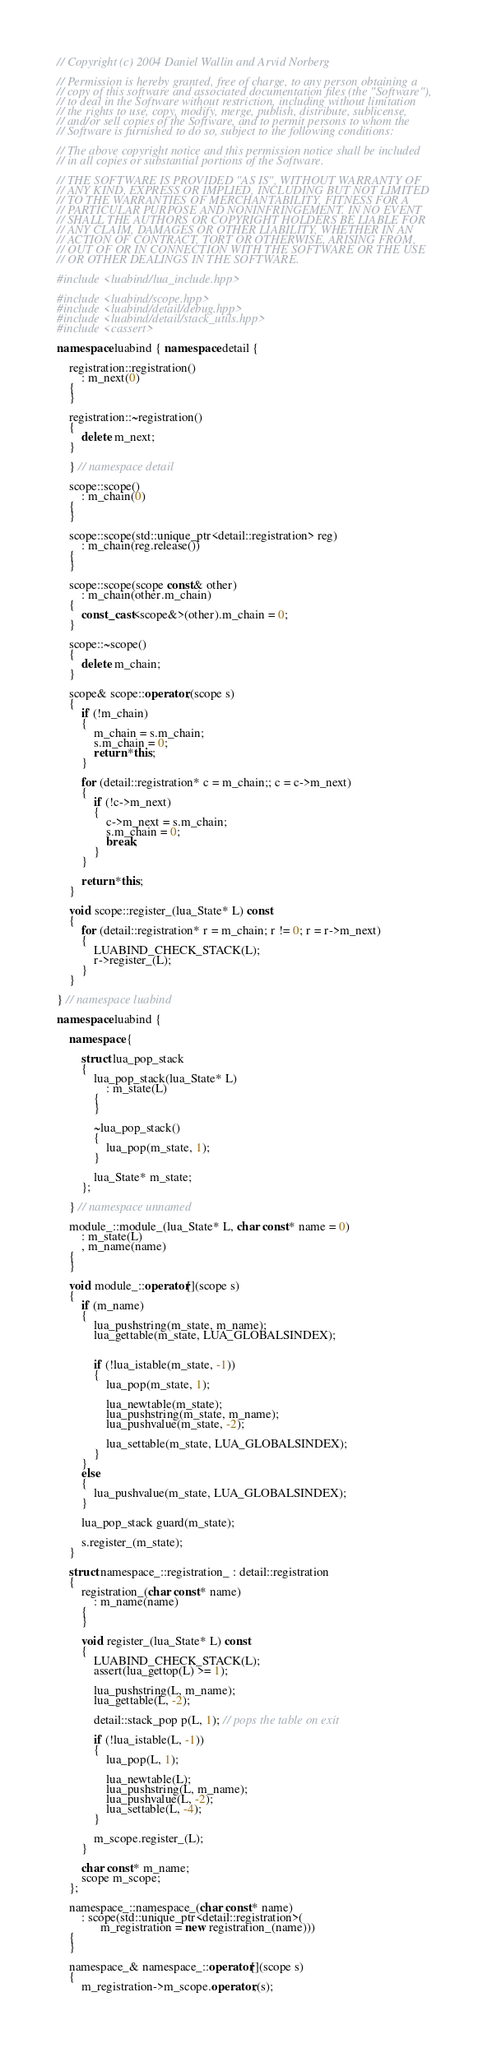Convert code to text. <code><loc_0><loc_0><loc_500><loc_500><_C++_>// Copyright (c) 2004 Daniel Wallin and Arvid Norberg

// Permission is hereby granted, free of charge, to any person obtaining a
// copy of this software and associated documentation files (the "Software"),
// to deal in the Software without restriction, including without limitation
// the rights to use, copy, modify, merge, publish, distribute, sublicense,
// and/or sell copies of the Software, and to permit persons to whom the
// Software is furnished to do so, subject to the following conditions:

// The above copyright notice and this permission notice shall be included
// in all copies or substantial portions of the Software.

// THE SOFTWARE IS PROVIDED "AS IS", WITHOUT WARRANTY OF
// ANY KIND, EXPRESS OR IMPLIED, INCLUDING BUT NOT LIMITED
// TO THE WARRANTIES OF MERCHANTABILITY, FITNESS FOR A
// PARTICULAR PURPOSE AND NONINFRINGEMENT. IN NO EVENT
// SHALL THE AUTHORS OR COPYRIGHT HOLDERS BE LIABLE FOR
// ANY CLAIM, DAMAGES OR OTHER LIABILITY, WHETHER IN AN
// ACTION OF CONTRACT, TORT OR OTHERWISE, ARISING FROM,
// OUT OF OR IN CONNECTION WITH THE SOFTWARE OR THE USE
// OR OTHER DEALINGS IN THE SOFTWARE.

#include <luabind/lua_include.hpp>

#include <luabind/scope.hpp>
#include <luabind/detail/debug.hpp>
#include <luabind/detail/stack_utils.hpp>
#include <cassert>

namespace luabind { namespace detail {

    registration::registration()
        : m_next(0)
    {
    }

    registration::~registration()
    {
        delete m_next;
    }

    } // namespace detail
    
    scope::scope()
        : m_chain(0)
    {
    }
    
    scope::scope(std::unique_ptr<detail::registration> reg)
        : m_chain(reg.release())
    {
    }

    scope::scope(scope const& other)
        : m_chain(other.m_chain)
    {
        const_cast<scope&>(other).m_chain = 0;
    }

    scope::~scope()
    {
        delete m_chain;
    }
    
    scope& scope::operator,(scope s)
    {
        if (!m_chain) 
        {
            m_chain = s.m_chain;
            s.m_chain = 0;
            return *this;
        }
        
        for (detail::registration* c = m_chain;; c = c->m_next)
        {
            if (!c->m_next)
            {
                c->m_next = s.m_chain;
                s.m_chain = 0;
                break;
            }
        }

        return *this;
    }

    void scope::register_(lua_State* L) const
    {
        for (detail::registration* r = m_chain; r != 0; r = r->m_next)
        {
			LUABIND_CHECK_STACK(L);
            r->register_(L);
        }
    }

} // namespace luabind

namespace luabind {

    namespace {

        struct lua_pop_stack
        {
            lua_pop_stack(lua_State* L)
                : m_state(L)
            {
            }

            ~lua_pop_stack()
            {
                lua_pop(m_state, 1);
            }

            lua_State* m_state;
        };

    } // namespace unnamed
    
    module_::module_(lua_State* L, char const* name = 0)
        : m_state(L)
        , m_name(name)
    {
    }

    void module_::operator[](scope s)
    {
        if (m_name)
        {
            lua_pushstring(m_state, m_name);
            lua_gettable(m_state, LUA_GLOBALSINDEX);


            if (!lua_istable(m_state, -1))
            {
                lua_pop(m_state, 1);

                lua_newtable(m_state);
                lua_pushstring(m_state, m_name);
                lua_pushvalue(m_state, -2);
                
                lua_settable(m_state, LUA_GLOBALSINDEX);
            }
        }
        else
        {
            lua_pushvalue(m_state, LUA_GLOBALSINDEX);
        }

        lua_pop_stack guard(m_state);

        s.register_(m_state);
    }

    struct namespace_::registration_ : detail::registration
    {
        registration_(char const* name)
            : m_name(name)
        {
        }

        void register_(lua_State* L) const
        {
			LUABIND_CHECK_STACK(L);
            assert(lua_gettop(L) >= 1);

            lua_pushstring(L, m_name);
            lua_gettable(L, -2);

			detail::stack_pop p(L, 1); // pops the table on exit

            if (!lua_istable(L, -1))
            {
                lua_pop(L, 1);

                lua_newtable(L);
                lua_pushstring(L, m_name);
                lua_pushvalue(L, -2);
                lua_settable(L, -4);
            }

            m_scope.register_(L);
        }

        char const* m_name;
        scope m_scope;
    };

    namespace_::namespace_(char const* name)
        : scope(std::unique_ptr<detail::registration>(
              m_registration = new registration_(name)))
    {
    }

    namespace_& namespace_::operator[](scope s)
    {
        m_registration->m_scope.operator,(s);        </code> 